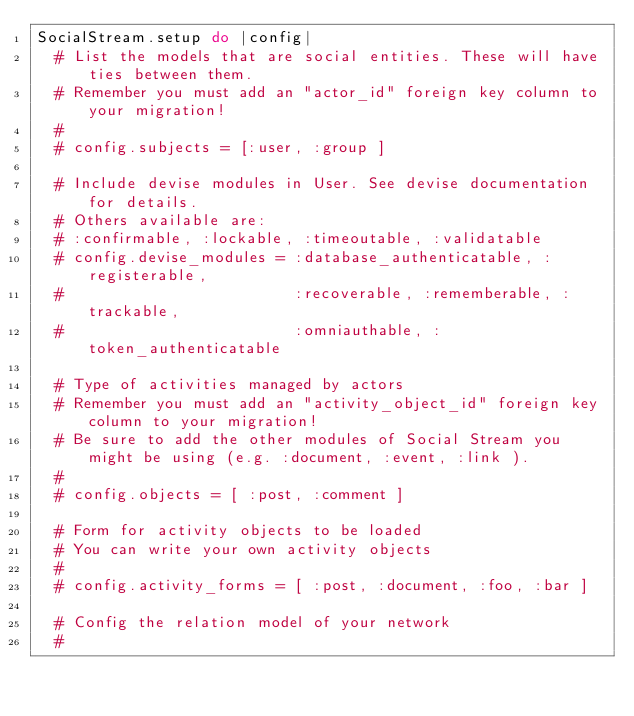<code> <loc_0><loc_0><loc_500><loc_500><_Ruby_>SocialStream.setup do |config|
  # List the models that are social entities. These will have ties between them.
  # Remember you must add an "actor_id" foreign key column to your migration!
  #
  # config.subjects = [:user, :group ]

  # Include devise modules in User. See devise documentation for details.
  # Others available are:
  # :confirmable, :lockable, :timeoutable, :validatable
  # config.devise_modules = :database_authenticatable, :registerable,
  #                         :recoverable, :rememberable, :trackable,
  #                         :omniauthable, :token_authenticatable

  # Type of activities managed by actors
  # Remember you must add an "activity_object_id" foreign key column to your migration!
  # Be sure to add the other modules of Social Stream you might be using (e.g. :document, :event, :link ).
  #
  # config.objects = [ :post, :comment ]

  # Form for activity objects to be loaded
  # You can write your own activity objects
  #
  # config.activity_forms = [ :post, :document, :foo, :bar ]

  # Config the relation model of your network
  #</code> 